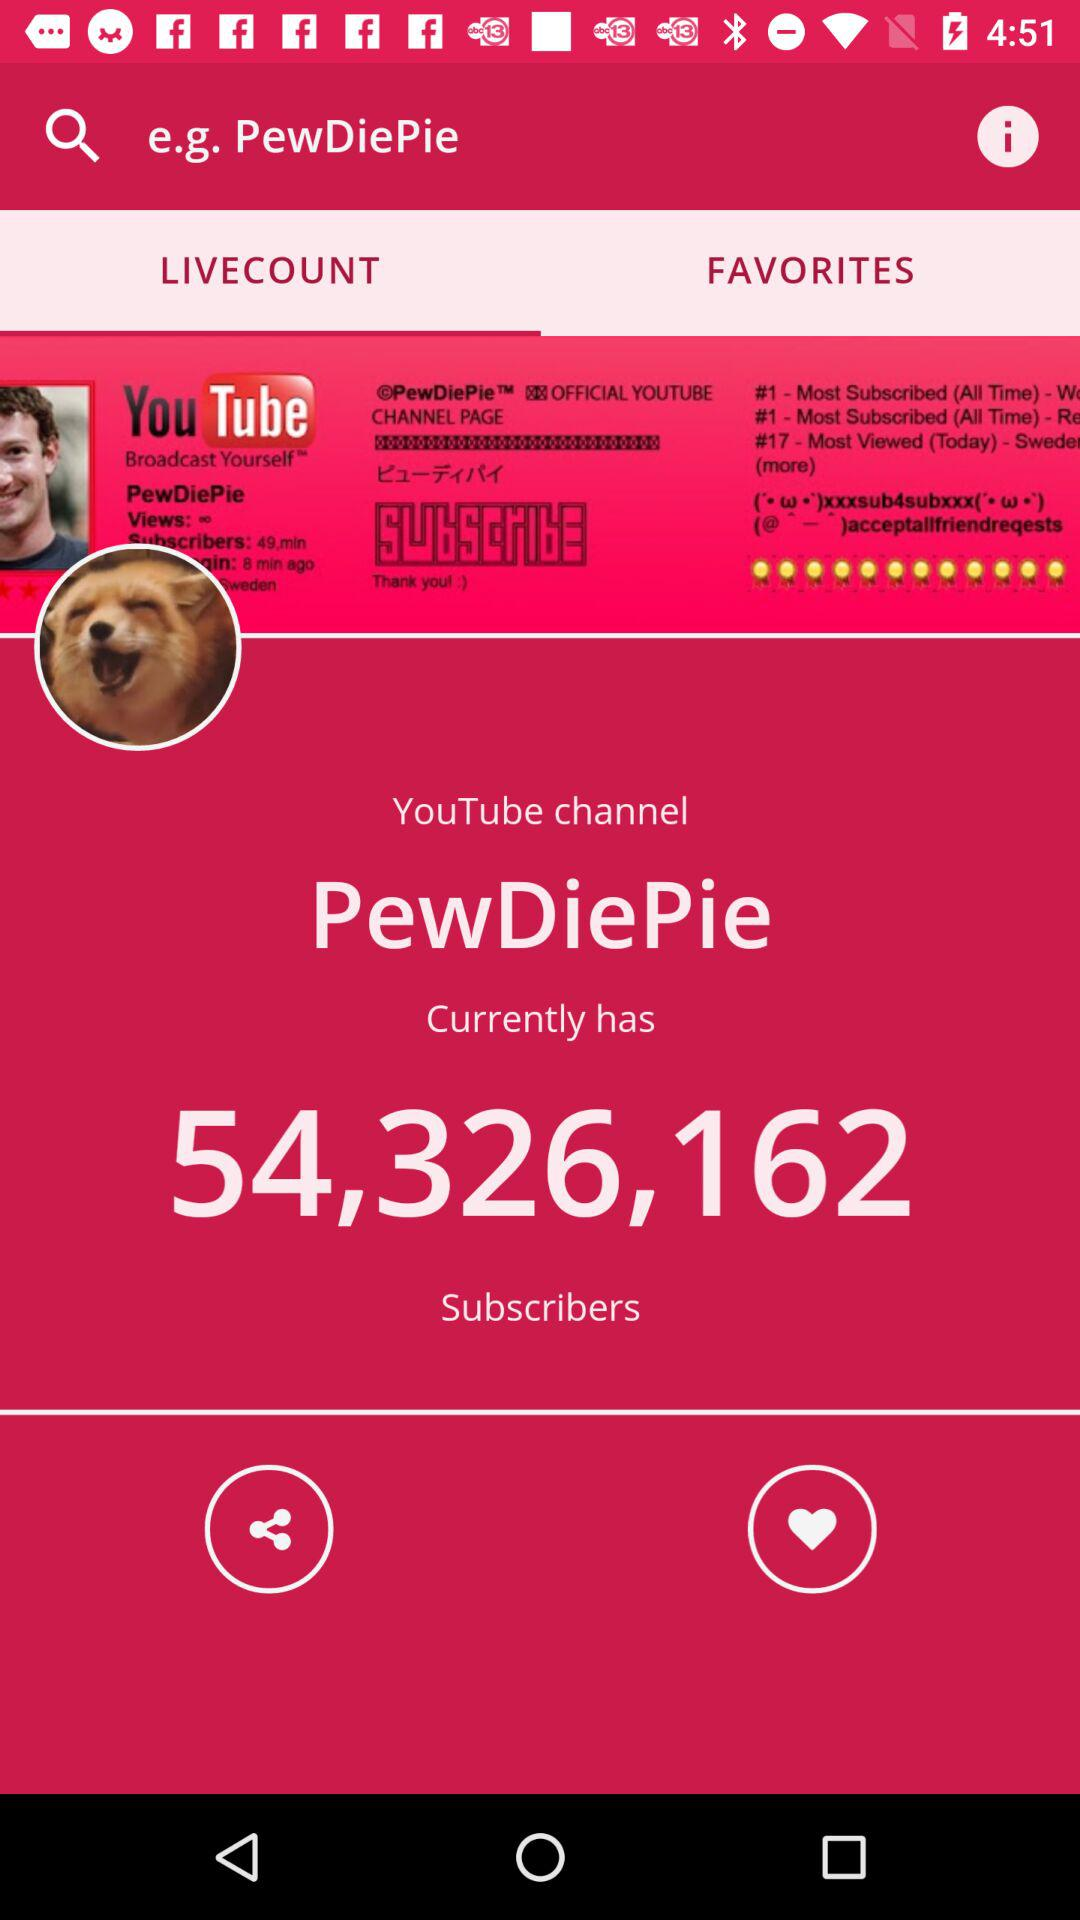How many subscribers does "PewDiePie" have? "PewDiePie" has 54,326,162 subscribers. 